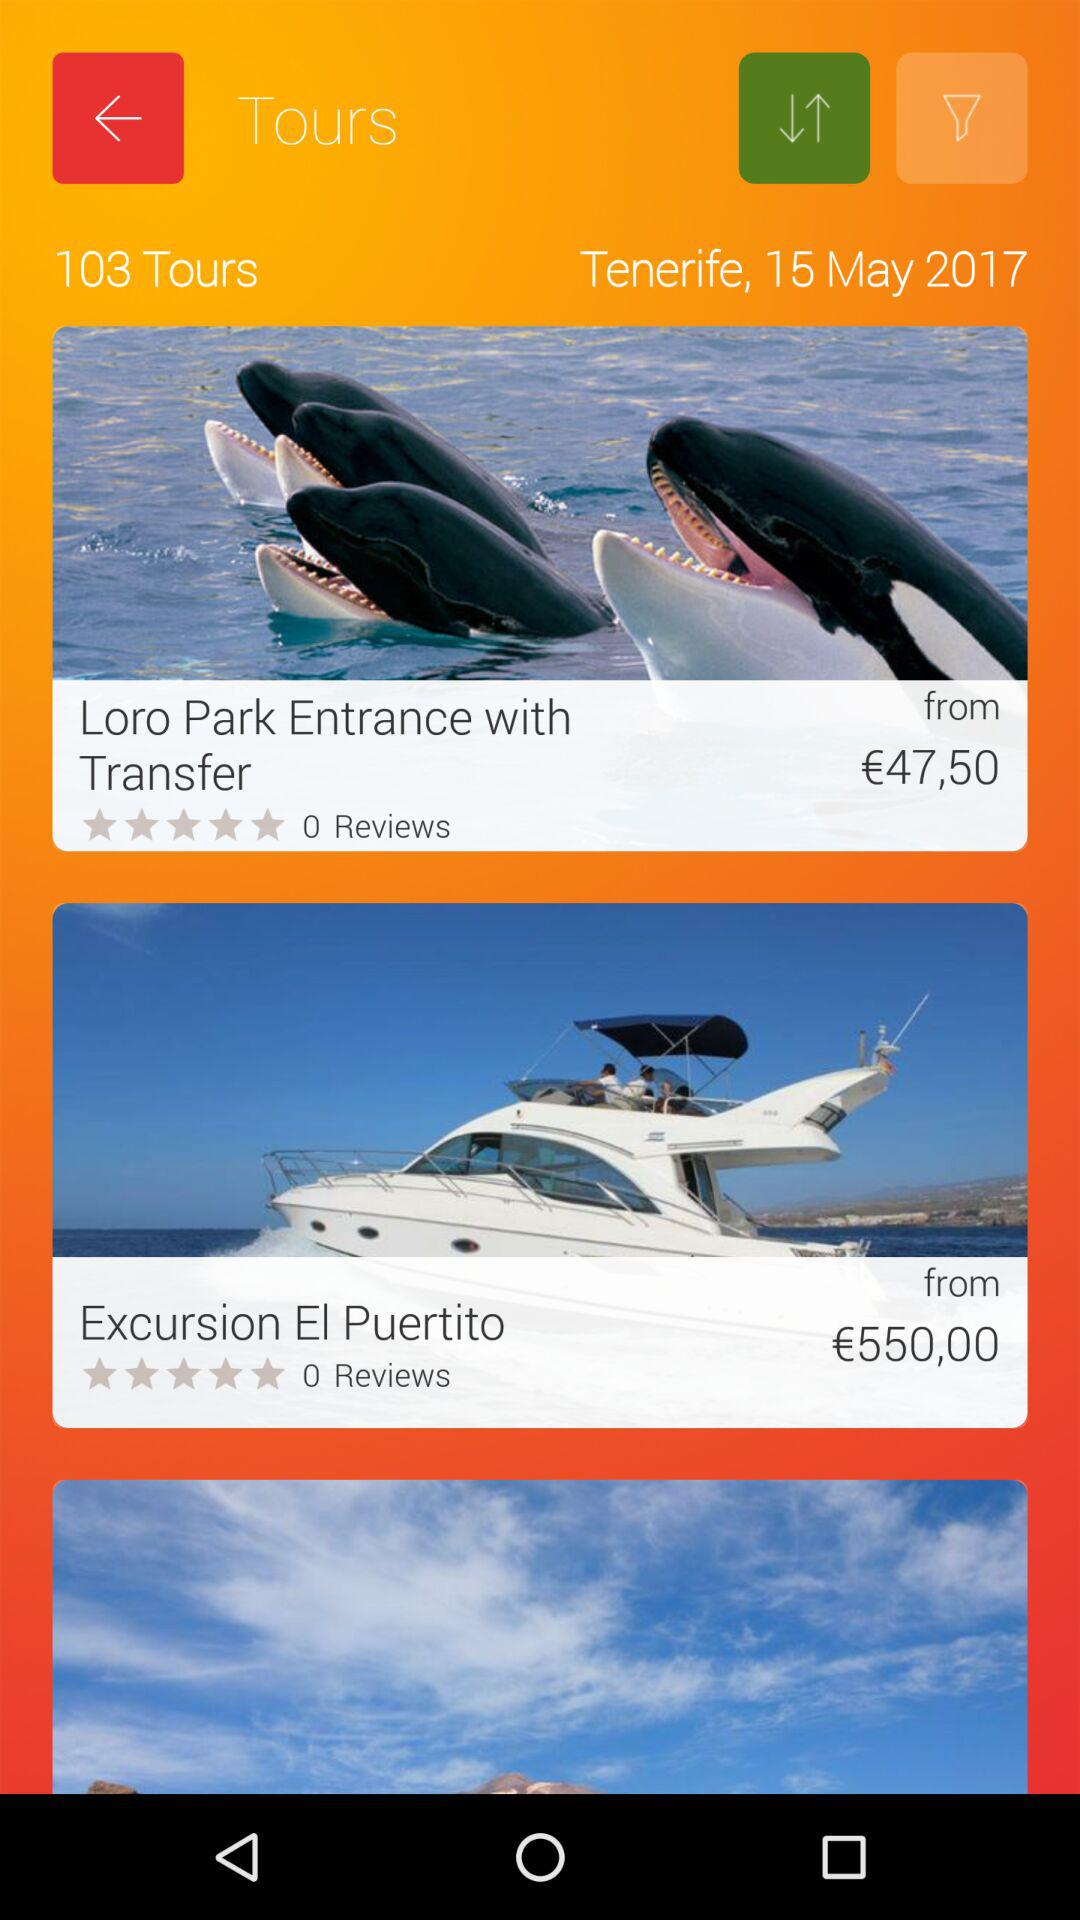What is the price for "Loro Park Entrance with Trasfer"? The price is €47,50. 